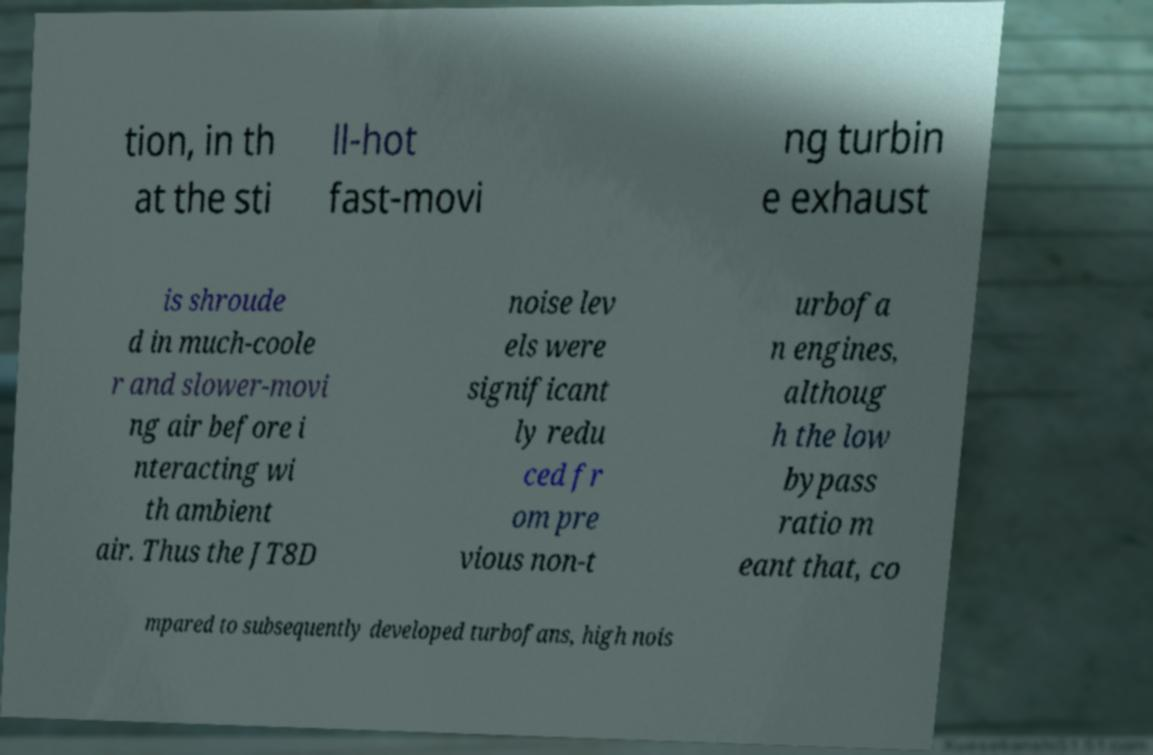Please identify and transcribe the text found in this image. tion, in th at the sti ll-hot fast-movi ng turbin e exhaust is shroude d in much-coole r and slower-movi ng air before i nteracting wi th ambient air. Thus the JT8D noise lev els were significant ly redu ced fr om pre vious non-t urbofa n engines, althoug h the low bypass ratio m eant that, co mpared to subsequently developed turbofans, high nois 